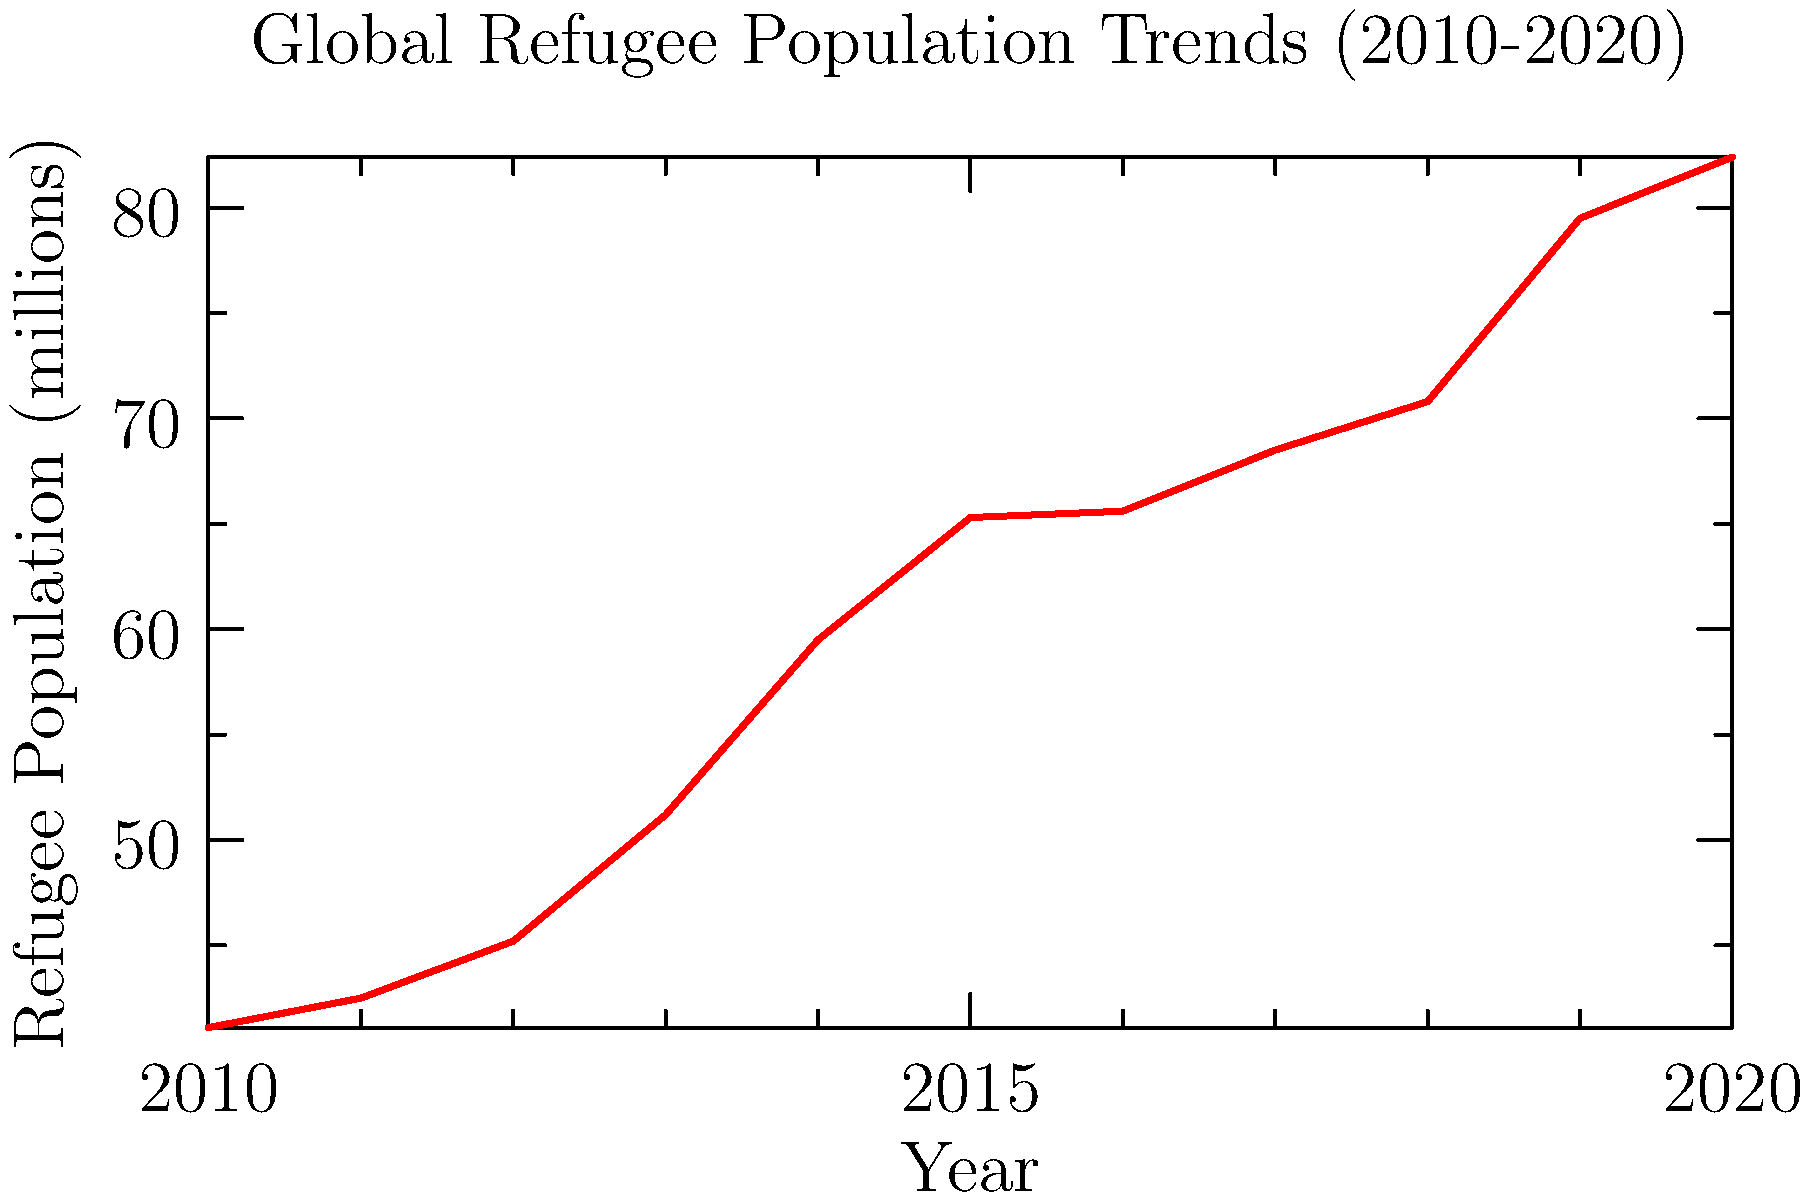Based on the line graph showing global refugee population trends from 2010 to 2020, what was the approximate percentage increase in the refugee population between 2010 and 2020? How might this trend impact national security policies and refugee assistance programs? To answer this question, we need to follow these steps:

1. Identify the refugee population values for 2010 and 2020:
   - 2010: 41.1 million
   - 2020: 82.4 million

2. Calculate the percentage increase:
   $\text{Percentage increase} = \frac{\text{Increase}}{\text{Original value}} \times 100\%$
   
   $\text{Increase} = 82.4 - 41.1 = 41.3$ million

   $\text{Percentage increase} = \frac{41.3}{41.1} \times 100\% \approx 100.5\%$

3. Round to the nearest whole number: 101%

The impact on national security policies and refugee assistance programs:

a) National security policies may become more stringent due to the increased influx of refugees, potentially leading to:
   - Stricter border controls
   - Enhanced screening processes
   - Increased international cooperation on refugee management

b) Refugee assistance programs would likely face significant challenges:
   - Increased demand for resources (e.g., housing, healthcare, education)
   - Need for expanded funding and personnel
   - Greater emphasis on integration and long-term support programs

c) The rapid increase might lead to debates on:
   - Balancing humanitarian obligations with national security concerns
   - Equitable distribution of refugees among host countries
   - Addressing root causes of forced displacement in source countries
Answer: 101% increase; potential for stricter security policies and overwhelmed assistance programs 